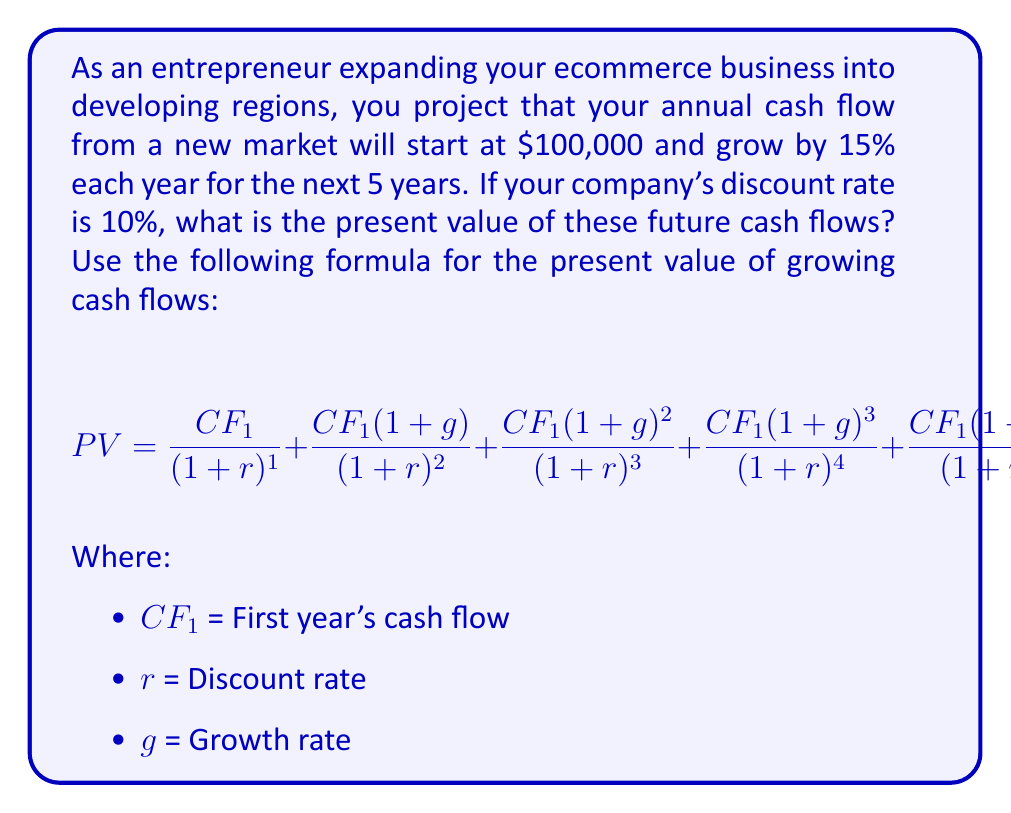Could you help me with this problem? To solve this problem, we'll use the given formula and plug in the values:

$CF_1 = \$100,000$
$r = 10\% = 0.10$
$g = 15\% = 0.15$

Let's calculate each term of the equation:

1. Year 1: $\frac{100,000}{(1+0.10)^1} = \frac{100,000}{1.10} = 90,909.09$

2. Year 2: $\frac{100,000(1+0.15)}{(1+0.10)^2} = \frac{115,000}{1.21} = 95,041.32$

3. Year 3: $\frac{100,000(1+0.15)^2}{(1+0.10)^3} = \frac{132,250}{1.331} = 99,361.38$

4. Year 4: $\frac{100,000(1+0.15)^3}{(1+0.10)^4} = \frac{152,087.50}{1.4641} = 103,877.81$

5. Year 5: $\frac{100,000(1+0.15)^4}{(1+0.10)^5} = \frac{174,900.63}{1.61051} = 108,598.84$

Now, we sum up all these values:

$PV = 90,909.09 + 95,041.32 + 99,361.38 + 103,877.81 + 108,598.84$

$PV = 497,788.44$
Answer: The present value of the future cash flows from international expansion is $497,788.44. 